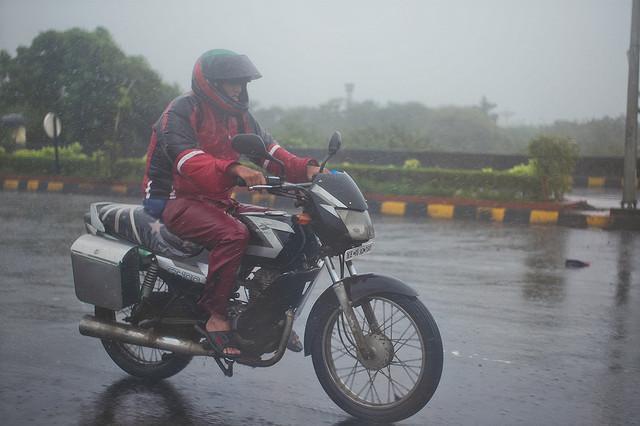How many reflections of a cat are visible?
Give a very brief answer. 0. 